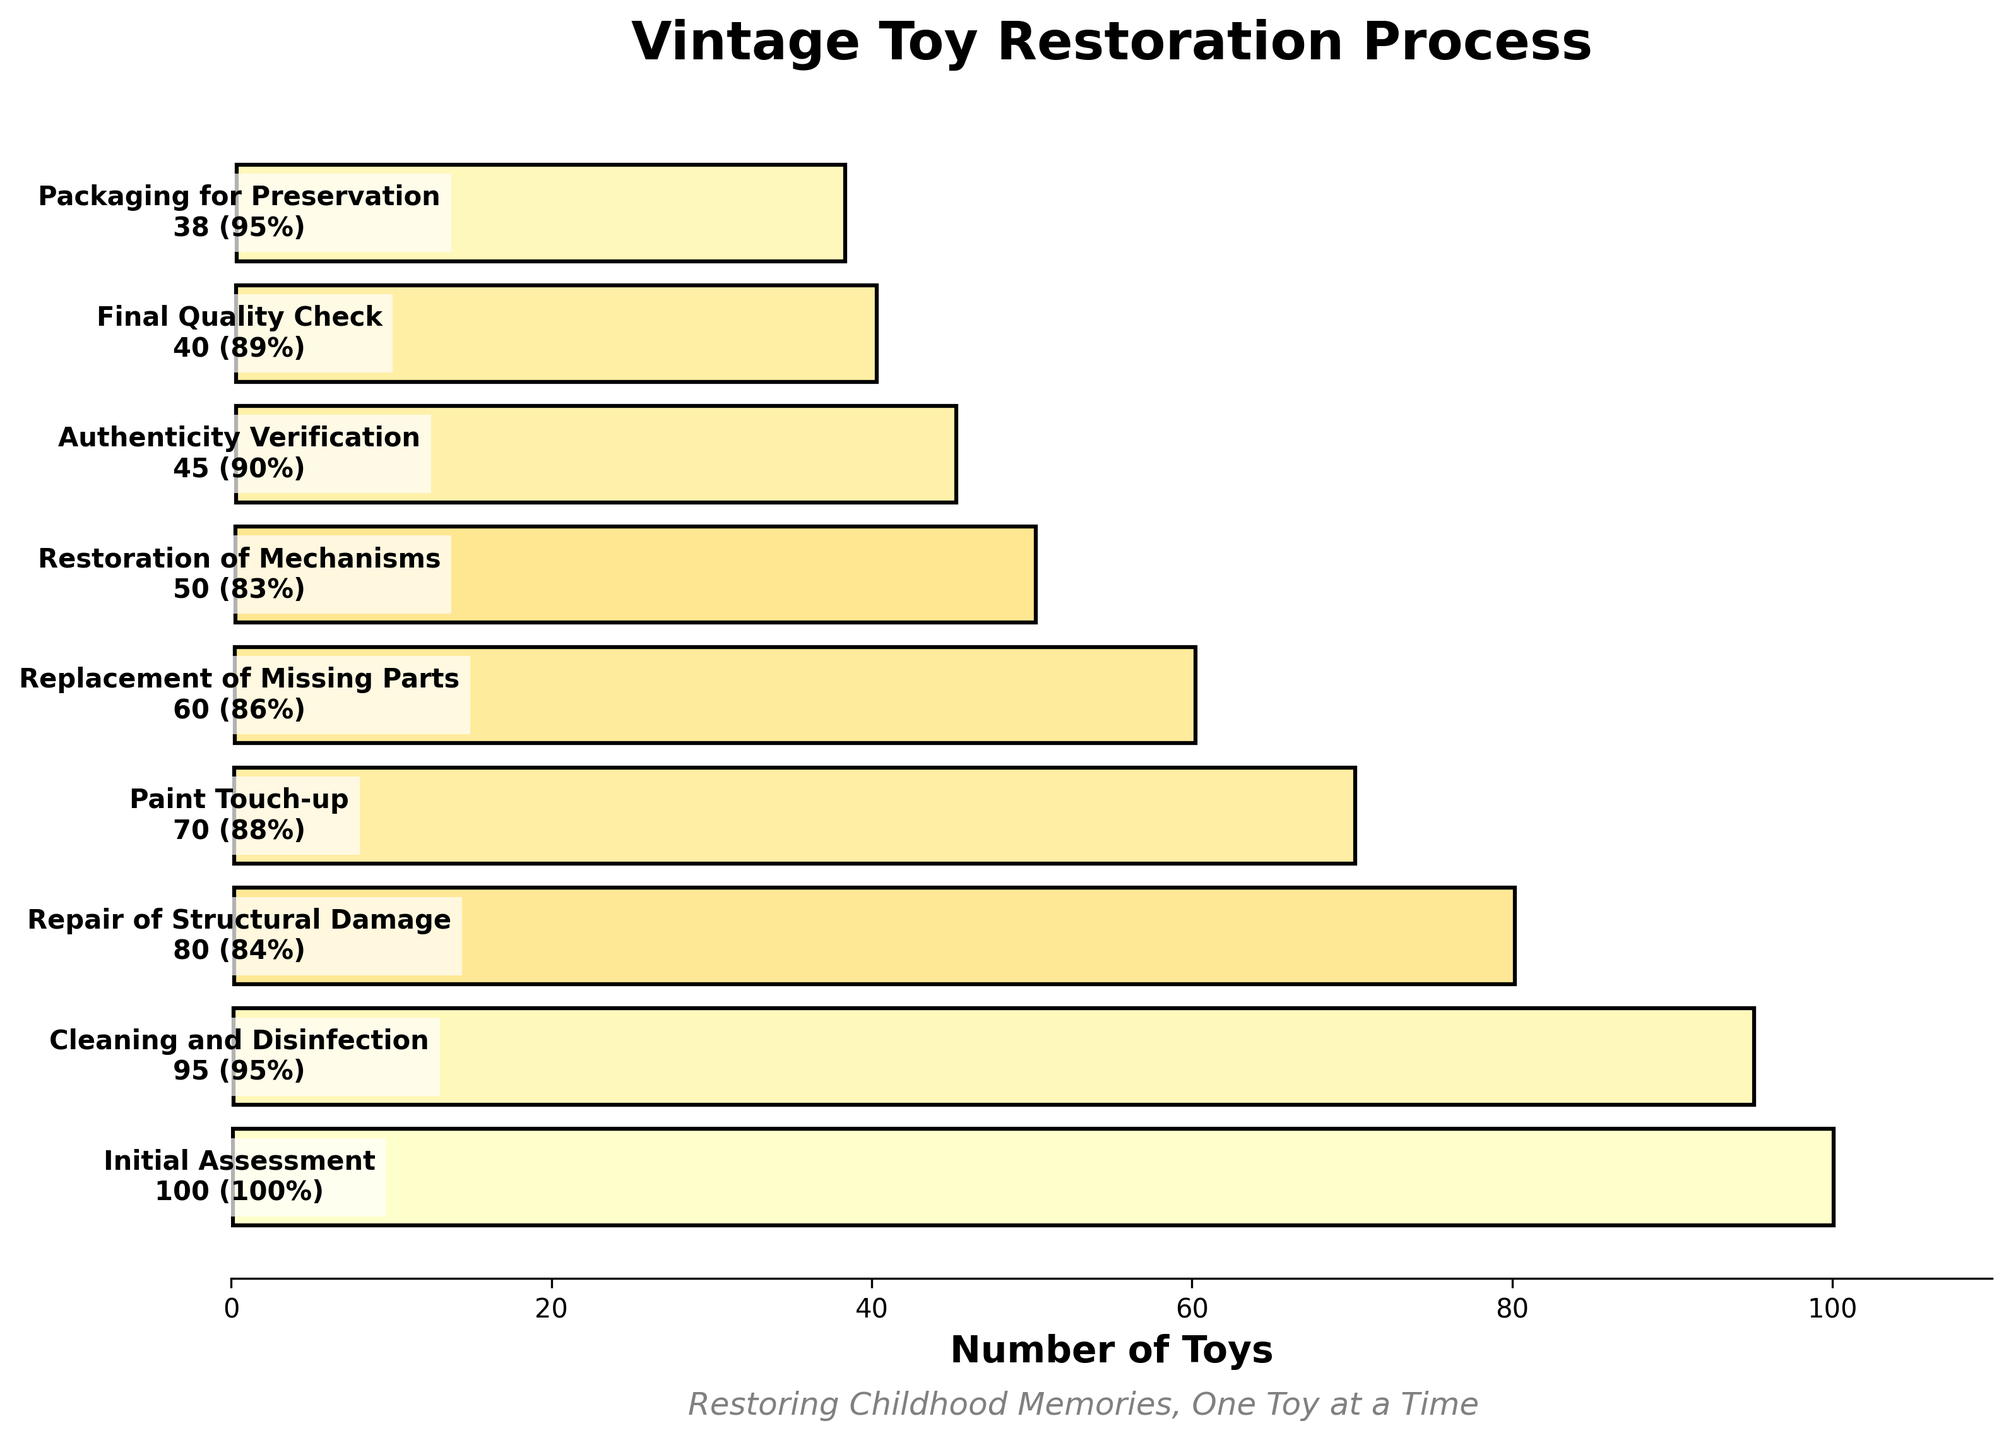What's the title of the chart? The title of the chart is at the top and clearly states what the chart is about. By reading the title, one can understand the main topic of the chart.
Answer: Vintage Toy Restoration Process What is the success rate during the Initial Assessment stage? Look at the success rate percentage next to the Initial Assessment stage on the chart.
Answer: 100% How many toys remain after the Repair of Structural Damage stage? Check the number of toys listed next to the Repair of Structural Damage stage in the chart.
Answer: 80 What is the difference in the number of toys between the Cleaning and Disinfection stage and the Packaging for Preservation stage? Identify the number of toys at the Cleaning and Disinfection stage and at the Packaging for Preservation stage, then subtract the latter from the former (95 - 38).
Answer: 57 Which stage has the highest success rate? Compare the success rates for all stages shown in the chart and identify the highest value.
Answer: Cleaning and Disinfection Which stage has the highest number of toys lost during the process? Calculate the difference in the number of toys between each successive stage and identify the largest decrease. The biggest drop is between Cleaning and Disinfection (95) to Repair of Structural Damage (80), which is (95 - 80) = 15 toys.
Answer: Cleaning and Disinfection to Repair of Structural Damage Are there any stages with identical success rates? Compare all the success rates listed next to each stage. If there are any matching values, note them. The final check is between the Cleaning and Disinfection stage at 95% and the Packaging for Preservation stage also at 95%.
Answer: Yes What's the average success rate across all stages? Add up all the success rates and divide by the number of stages. (100 + 95 + 84 + 88 + 86 + 83 + 90 + 89 + 95) / 9 = 90%.
Answer: 90% Which two stages combined have a total number of toys of 108? Check pairs of stages and sum their number of toys until you find the pair that equals 108 (80 + 28 = 108). The effective stages here would be from Repair of Structural Damage and Final Quality Check.
Answer: Repair of Structural Damage and Packaging for Preservation? 